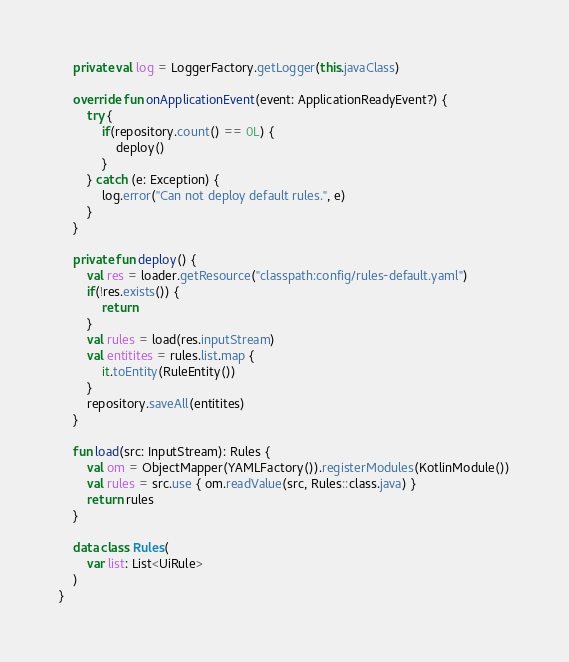Convert code to text. <code><loc_0><loc_0><loc_500><loc_500><_Kotlin_>
    private val log = LoggerFactory.getLogger(this.javaClass)

    override fun onApplicationEvent(event: ApplicationReadyEvent?) {
        try {
            if(repository.count() == 0L) {
                deploy()
            }
        } catch (e: Exception) {
            log.error("Can not deploy default rules.", e)
        }
    }

    private fun deploy() {
        val res = loader.getResource("classpath:config/rules-default.yaml")
        if(!res.exists()) {
            return
        }
        val rules = load(res.inputStream)
        val entitites = rules.list.map {
            it.toEntity(RuleEntity())
        }
        repository.saveAll(entitites)
    }

    fun load(src: InputStream): Rules {
        val om = ObjectMapper(YAMLFactory()).registerModules(KotlinModule())
        val rules = src.use { om.readValue(src, Rules::class.java) }
        return rules
    }

    data class Rules(
        var list: List<UiRule>
    )
}
</code> 